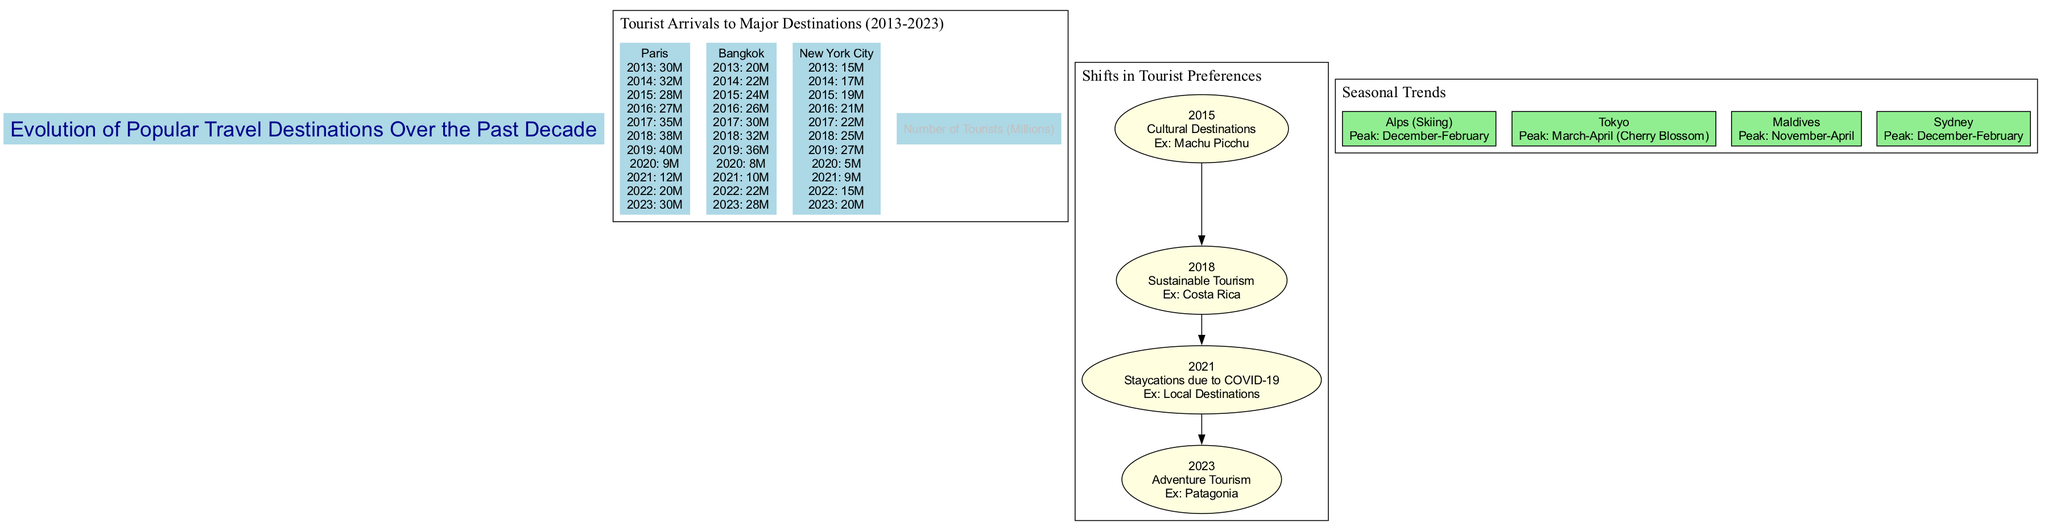What was the number of tourists in Paris in 2019? According to the diagram, the line graph clearly indicates that the number of tourists in Paris for the year 2019 is represented by 40 million. By locating Paris on the line graph and checking the data point for that year, the exact figure is determined.
Answer: 40 million Which destination had the highest number of tourists in 2017? The line graph includes data for 2017, where we can see the number of tourists for each destination. Paris has 35 million, Bangkok has 30 million, and New York City has 22 million. Comparing these values, Paris had the highest number of tourists in that year.
Answer: Paris What preference shift occurred in 2021? From the infographic section, it states that in 2021, the preferred travel shifted to staycations due to COVID-19. By referencing the labeled year in the infographic, the specific example of local destinations also supports this shift.
Answer: Staycations due to COVID-19 What is the peak season for skiing in the Alps? The seasonal trends infographic indicates that the peak season for skiing in the Alps is identified as December-February. This is specifically stated next to the Alps destination in the seasonal trends section of the diagram.
Answer: December-February Which destination had a surge in tourists from 2022 to 2023? To answer this, we review the data points from the line graph for the year 2022 and the year 2023 for each destination. Paris had 20 million tourists in 2022, and 30 million in 2023, indicating a surge of 10 million. This comparison shows that Paris significantly increased its tourist arrivals over that period.
Answer: Paris What shift in tourist preferences was noted for the year 2015? According to the infographic on shifts in preferences, the year 2015 is associated with cultural destinations, such as Machu Picchu. This information is explicitly outlined in the corresponding section of the diagram.
Answer: Cultural Destinations What was the trend for New York City in the year 2020? The line graph shows that in 2020, New York City had a significantly lower number of tourists, specifically 5 million. To find this, one can cross-reference the year's data point for New York City on the graph.
Answer: 5 million How many destinations are represented in the tourist arrivals line graph? By analyzing the line graph, it shows three distinct destinations: Paris, Bangkok, and New York City. The total number of data series listed confirms this number.
Answer: Three 